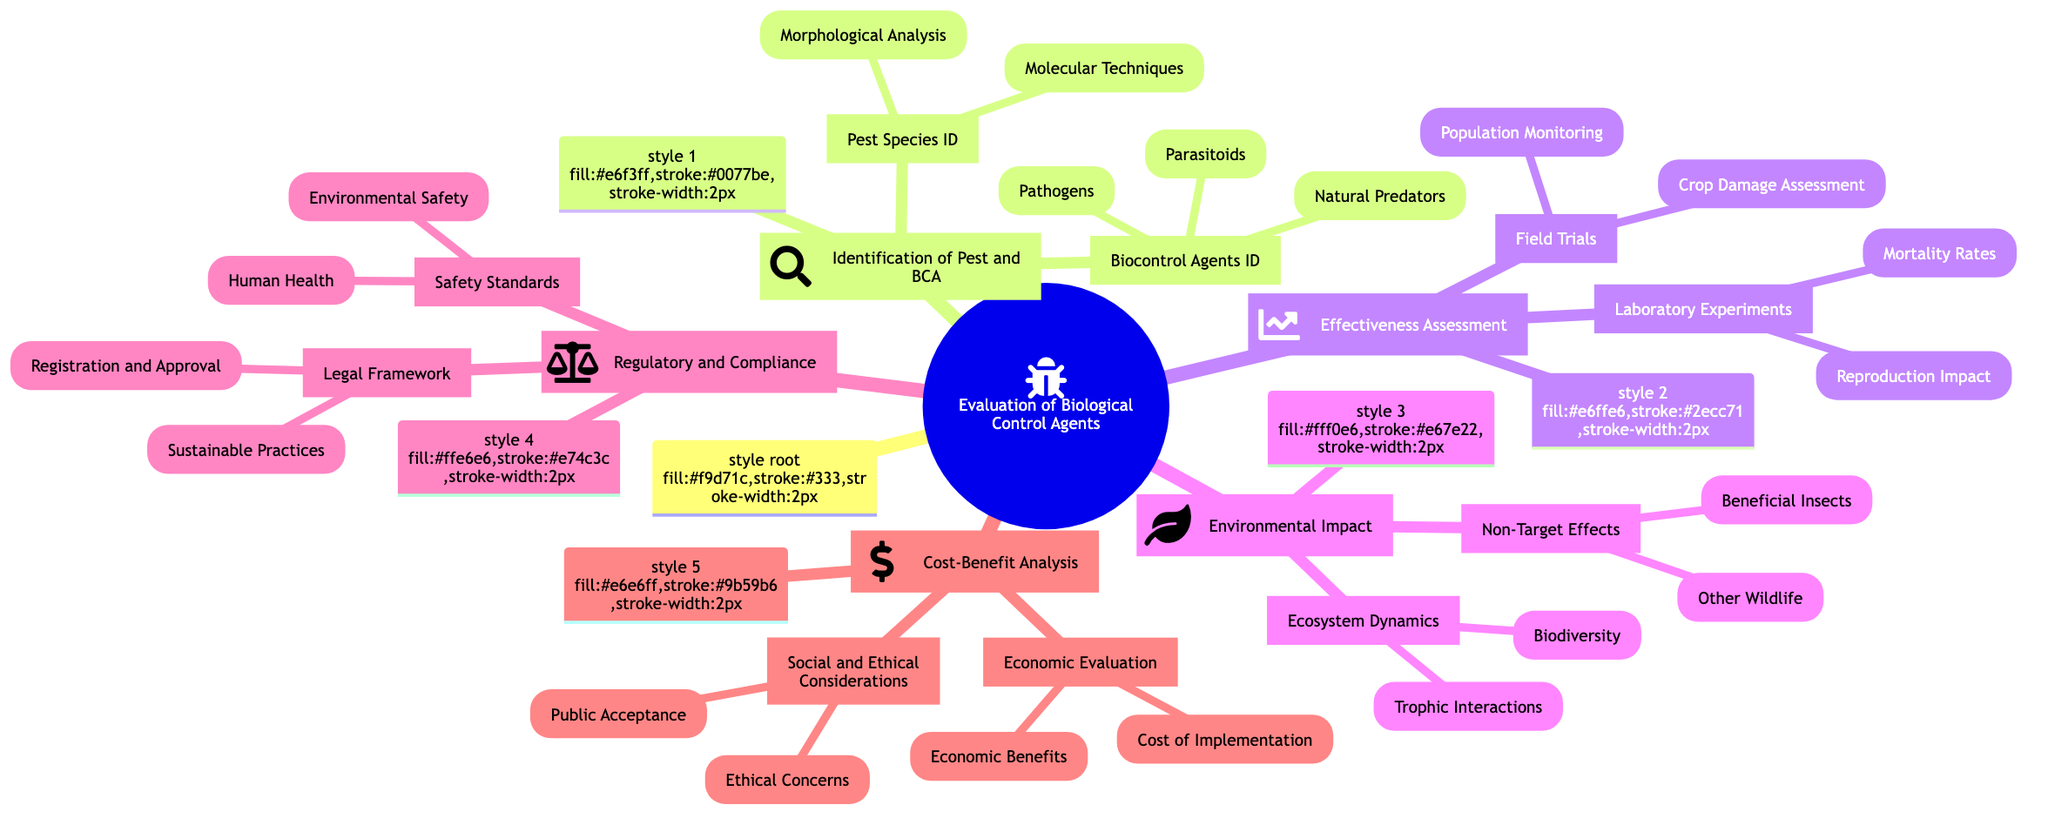What is the primary focus of the mind map? The central node "Evaluation of Biological Control Agents" indicates that the entire diagram revolves around evaluating methods of biological pest control.
Answer: Evaluation of Biological Control Agents How many main categories are present in the diagram? There are five main categories branching from the root: Identification of Pest and Biological Control Agents, Effectiveness Assessment, Environmental Impact, Regulatory and Compliance, and Cost-Benefit Analysis.
Answer: Five What techniques are listed under Pest Species Identification? The Pest Species Identification node includes Morphological Analysis and Molecular Techniques as its subcategories.
Answer: Morphological Analysis, Molecular Techniques Which evaluation aspect includes "Yield Improvement"? Under Cost-Benefit Analysis, the Economic Evaluation subcategory includes Economic Benefits which specifically mentions Yield Improvement.
Answer: Economic Benefits What are the two types of Non-Target Effects mentioned? The Non-Target Effects subcategory specifies Beneficial Insects and Other Wildlife as its two types.
Answer: Beneficial Insects, Other Wildlife Which regulatory aspect pertains to Human Health? The Safety Standards category under Regulatory and Compliance directly pertains to Human Health as it includes Toxicity Testing and Residue Limits.
Answer: Safety Standards How does the Effectiveness Assessment differentiate between Laboratory Experiments and Field Trials? The Effectiveness Assessment node is divided into two distinct subcategories; Laboratory Experiments examines controlled settings while Field Trials assesses real-world conditions.
Answer: Laboratory Experiments, Field Trials What does the Legal Framework category include? The Legal Framework includes two subcategories: Registration and Approval, and Sustainable Practices.
Answer: Registration and Approval, Sustainable Practices Which category addresses ethical considerations? The Social and Ethical Considerations subcategory under Cost-Benefit Analysis specifically addresses ethical considerations in the evaluation process.
Answer: Social and Ethical Considerations 